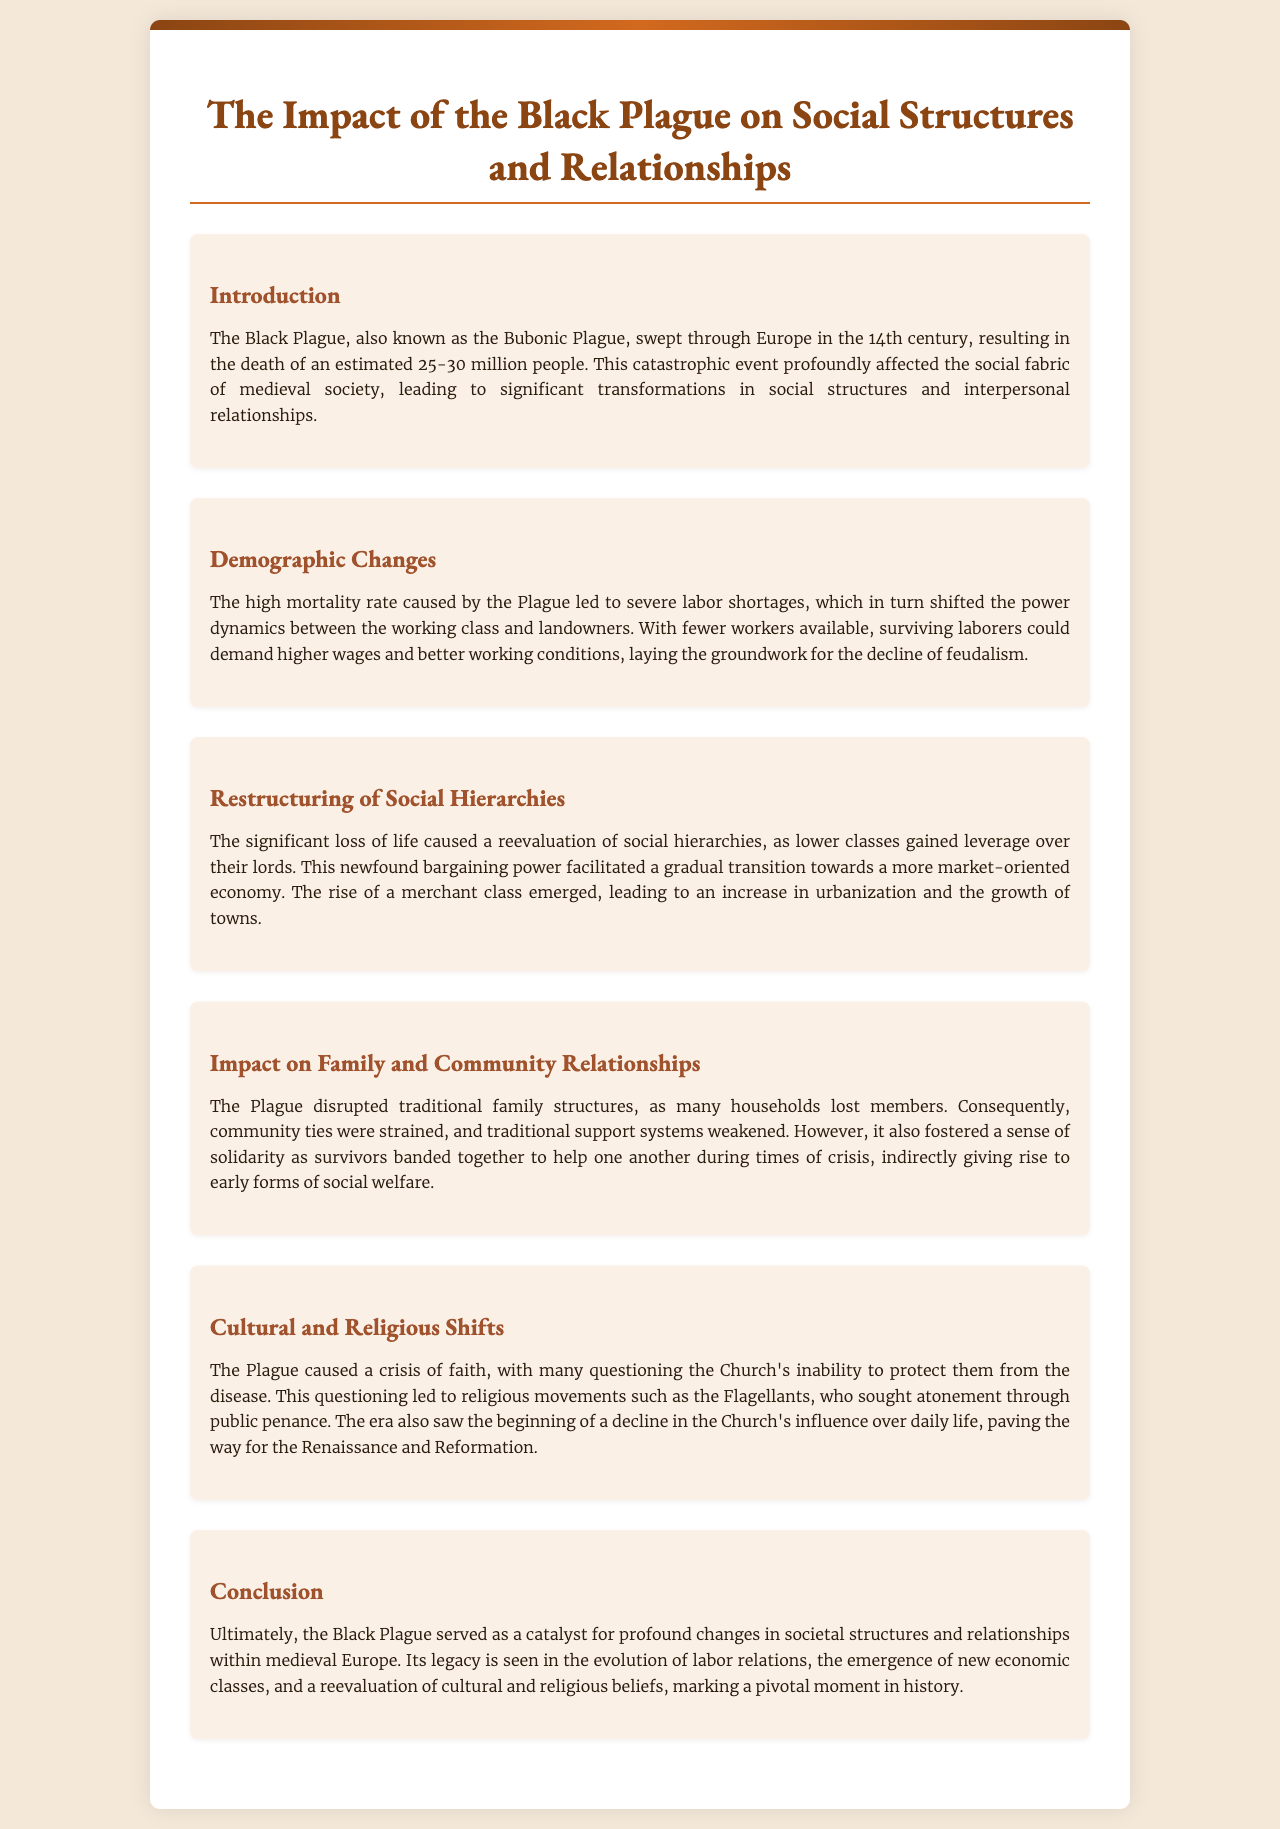what is the estimated number of people who died due to the Black Plague? The document states that the Black Plague resulted in the death of an estimated 25-30 million people.
Answer: 25-30 million what effect did the labor shortages caused by the Plague have on workers? The text explains that surviving laborers could demand higher wages and better working conditions due to labor shortages.
Answer: Higher wages what social class emerged due to the restructuring of social hierarchies after the Plague? The document mentions the rise of a merchant class as a result of the changes in social hierarchies.
Answer: Merchant class how did the Black Plague affect traditional family structures? The text states that many households lost members, resulting in a disruption of traditional family structures.
Answer: Disruption what religious movement sought atonement through public penance? The document references the Flagellants as a movement that sought atonement through public penance during the Plague.
Answer: Flagellants how did the Plague contribute to the decline of feudalism? The reasoning in the document indicates that labor shortages allowed workers to demand higher wages, leading to a decline of feudalism.
Answer: Shift in power dynamics what significant crisis did the Plague cause among people regarding religion? The document illustrates that the Plague caused a crisis of faith regarding the Church's inability to protect them.
Answer: Crisis of faith what is a key legacy of the Black Plague in societal structures? The conclusion outlines that the Black Plague served as a catalyst for profound changes in societal structures, among other legacies.
Answer: Catalyst for change 